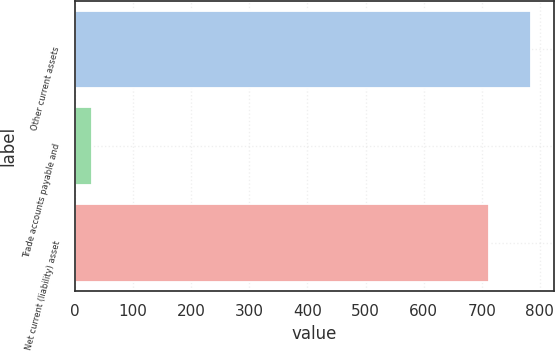<chart> <loc_0><loc_0><loc_500><loc_500><bar_chart><fcel>Other current assets<fcel>Trade accounts payable and<fcel>Net current (liability) asset<nl><fcel>784.3<fcel>30<fcel>713<nl></chart> 